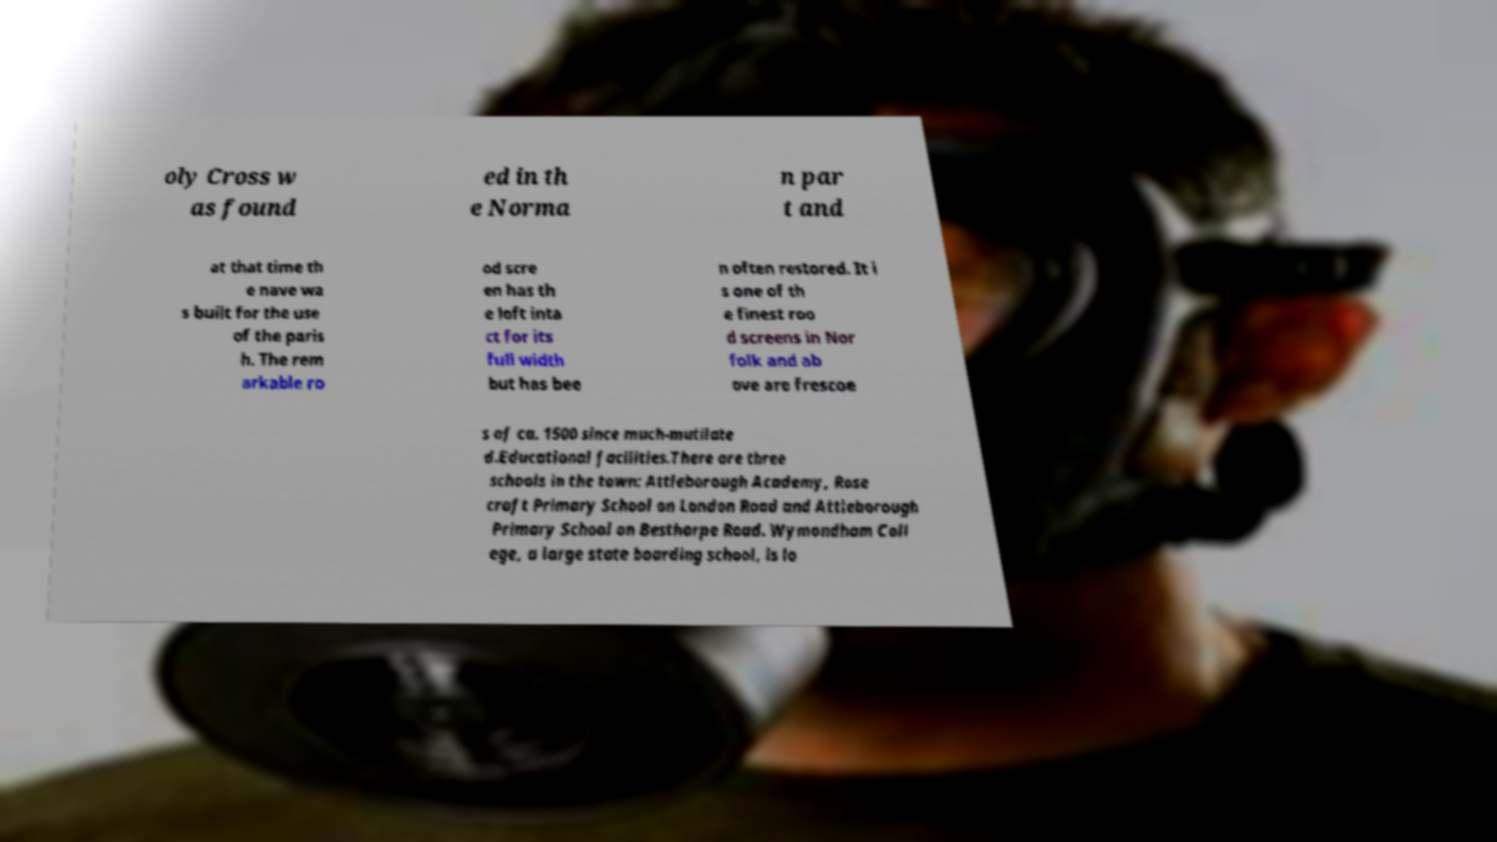What messages or text are displayed in this image? I need them in a readable, typed format. oly Cross w as found ed in th e Norma n par t and at that time th e nave wa s built for the use of the paris h. The rem arkable ro od scre en has th e loft inta ct for its full width but has bee n often restored. It i s one of th e finest roo d screens in Nor folk and ab ove are frescoe s of ca. 1500 since much-mutilate d.Educational facilities.There are three schools in the town: Attleborough Academy, Rose croft Primary School on London Road and Attleborough Primary School on Besthorpe Road. Wymondham Coll ege, a large state boarding school, is lo 